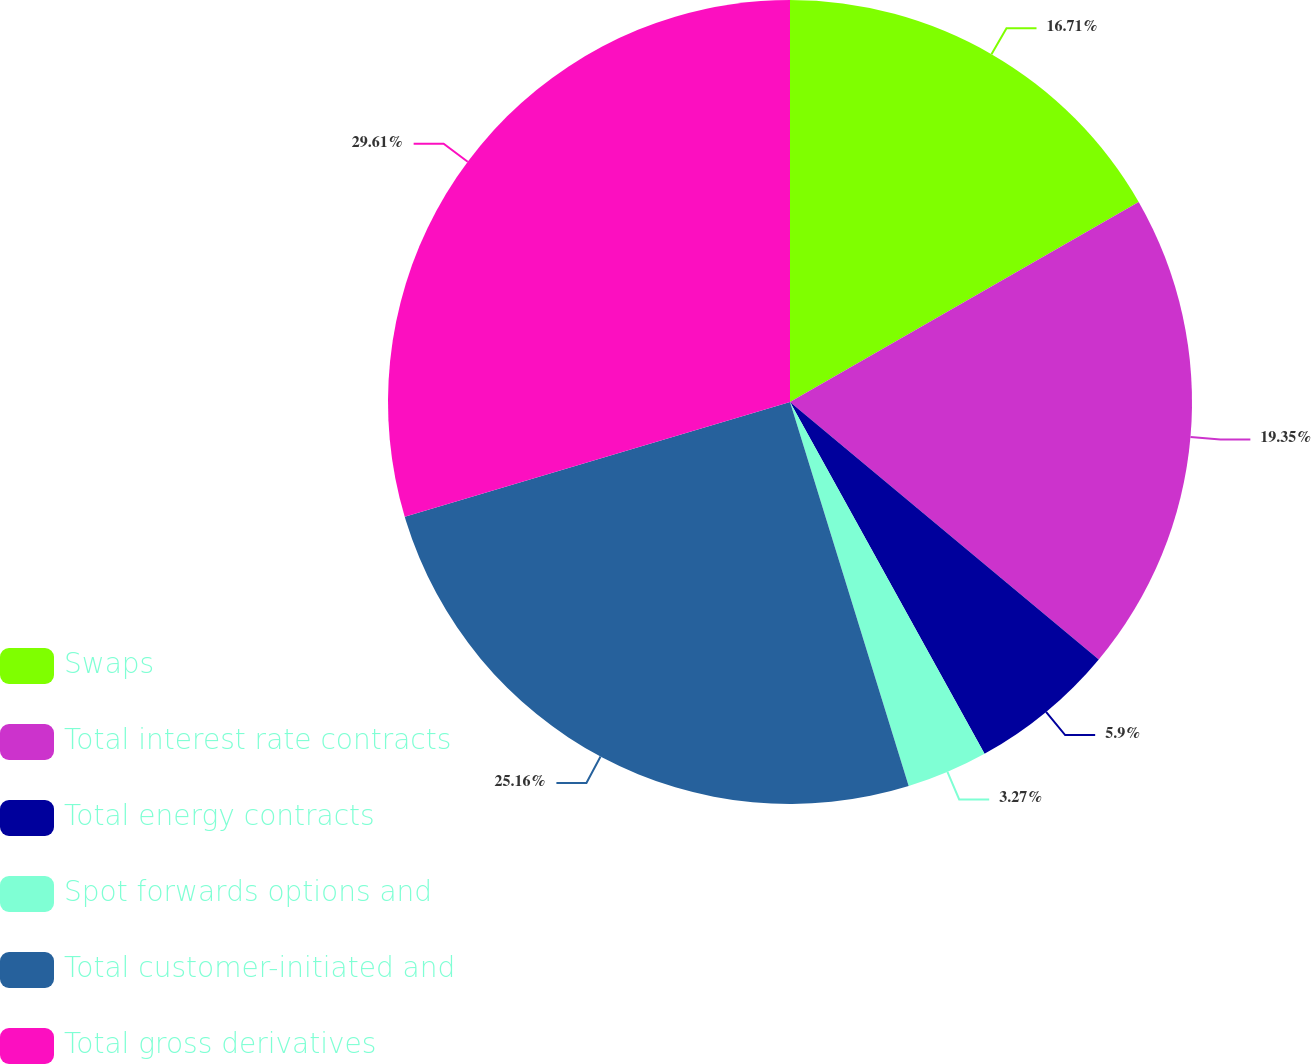Convert chart to OTSL. <chart><loc_0><loc_0><loc_500><loc_500><pie_chart><fcel>Swaps<fcel>Total interest rate contracts<fcel>Total energy contracts<fcel>Spot forwards options and<fcel>Total customer-initiated and<fcel>Total gross derivatives<nl><fcel>16.71%<fcel>19.35%<fcel>5.9%<fcel>3.27%<fcel>25.16%<fcel>29.61%<nl></chart> 